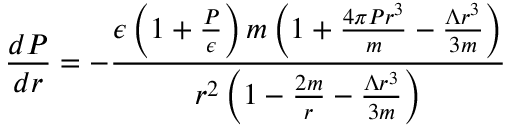<formula> <loc_0><loc_0><loc_500><loc_500>\frac { d P } { d r } = - \frac { \epsilon \left ( 1 + \frac { P } { \epsilon } \right ) m \left ( 1 + \frac { 4 \pi P r ^ { 3 } } { m } - \frac { \Lambda r ^ { 3 } } { 3 m } \right ) } { r ^ { 2 } \left ( 1 - \frac { 2 m } { r } - \frac { \Lambda r ^ { 3 } } { 3 m } \right ) }</formula> 